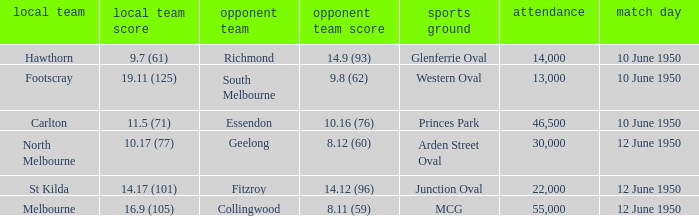What was the crowd when the VFL played MCG? 55000.0. 